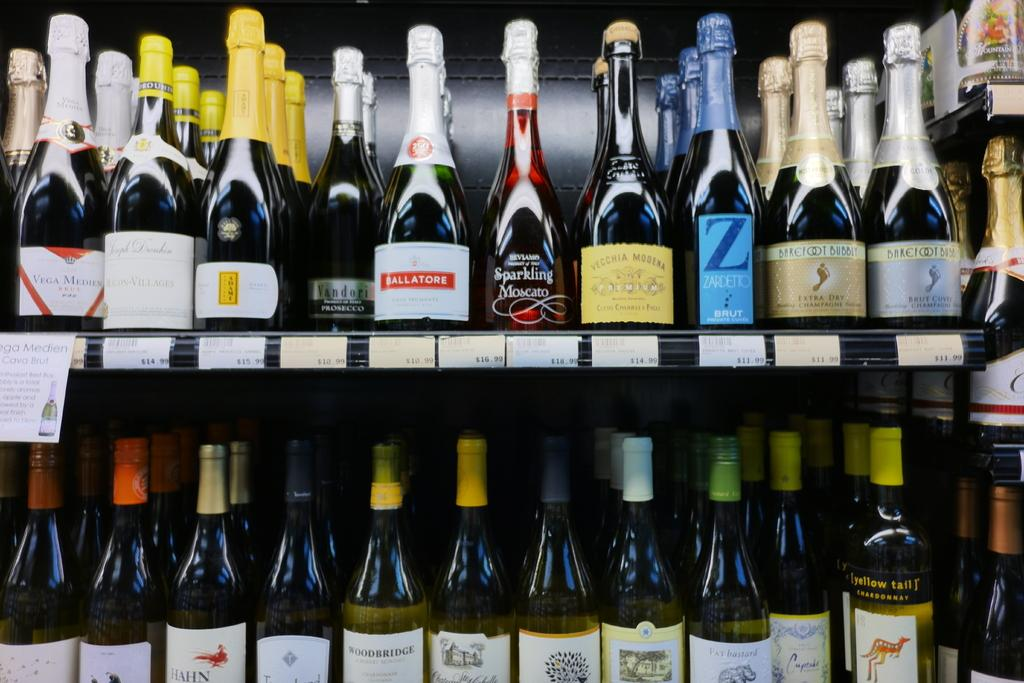<image>
Provide a brief description of the given image. the wine bottle that says sparkling moscato on it 